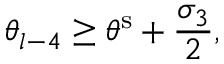Convert formula to latex. <formula><loc_0><loc_0><loc_500><loc_500>\theta _ { l - 4 } \geq \theta ^ { s } + \frac { \sigma _ { 3 } } { 2 } ,</formula> 